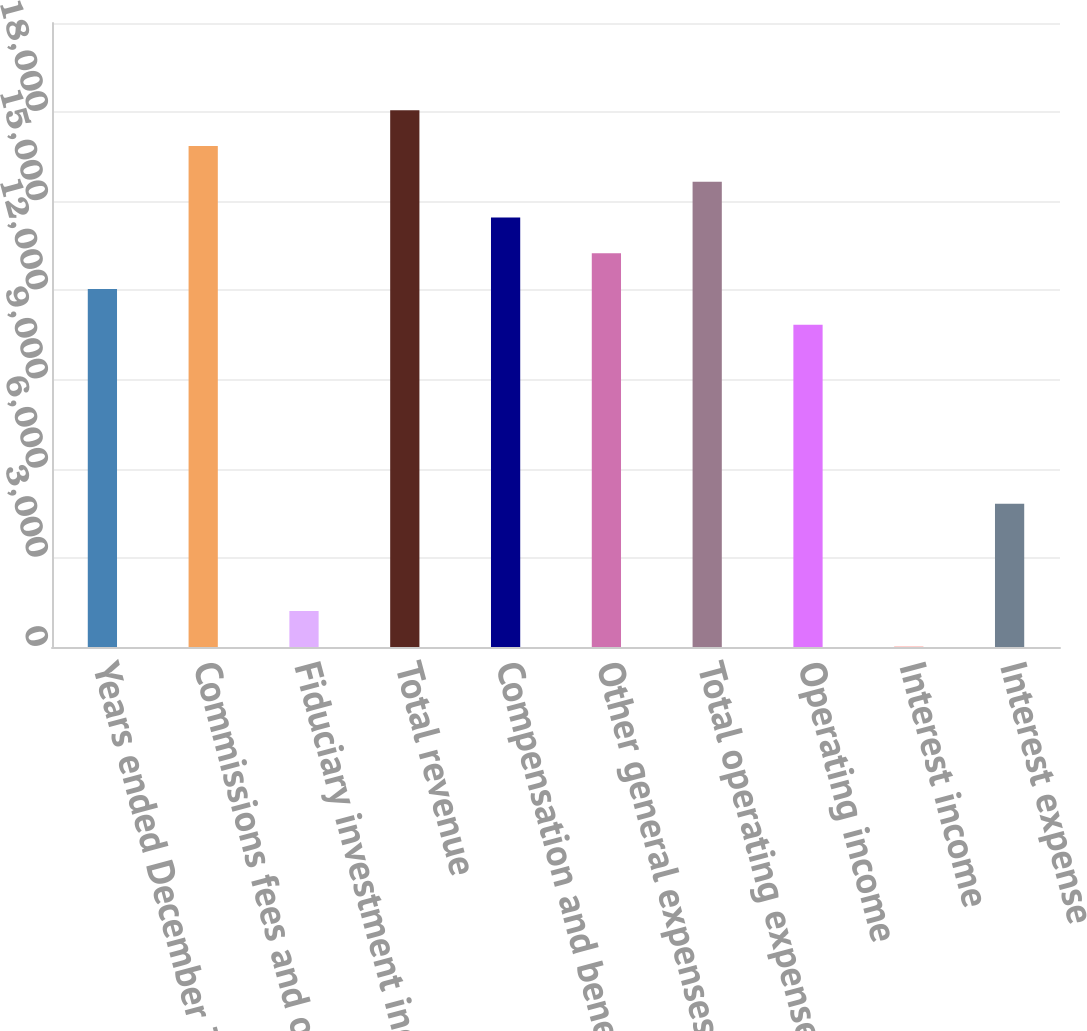Convert chart. <chart><loc_0><loc_0><loc_500><loc_500><bar_chart><fcel>Years ended December 31<fcel>Commissions fees and other<fcel>Fiduciary investment income<fcel>Total revenue<fcel>Compensation and benefits<fcel>Other general expenses<fcel>Total operating expenses<fcel>Operating income<fcel>Interest income<fcel>Interest expense<nl><fcel>12045<fcel>16859<fcel>1213.5<fcel>18062.5<fcel>14452<fcel>13248.5<fcel>15655.5<fcel>10841.5<fcel>10<fcel>4824<nl></chart> 